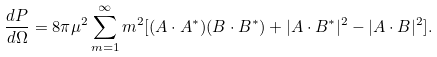Convert formula to latex. <formula><loc_0><loc_0><loc_500><loc_500>\frac { d P } { d \Omega } = 8 \pi \mu ^ { 2 } \sum _ { m = 1 } ^ { \infty } m ^ { 2 } [ ( A \cdot A ^ { * } ) ( B \cdot B ^ { * } ) + | A \cdot B ^ { * } | ^ { 2 } - | A \cdot B | ^ { 2 } ] .</formula> 